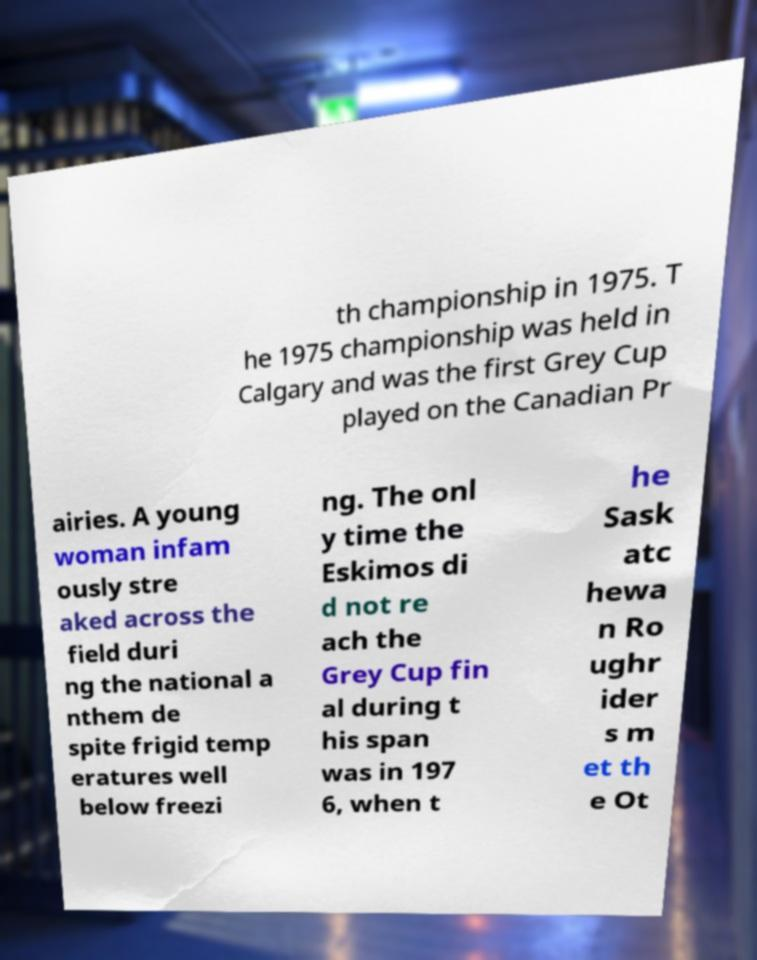Can you accurately transcribe the text from the provided image for me? th championship in 1975. T he 1975 championship was held in Calgary and was the first Grey Cup played on the Canadian Pr airies. A young woman infam ously stre aked across the field duri ng the national a nthem de spite frigid temp eratures well below freezi ng. The onl y time the Eskimos di d not re ach the Grey Cup fin al during t his span was in 197 6, when t he Sask atc hewa n Ro ughr ider s m et th e Ot 